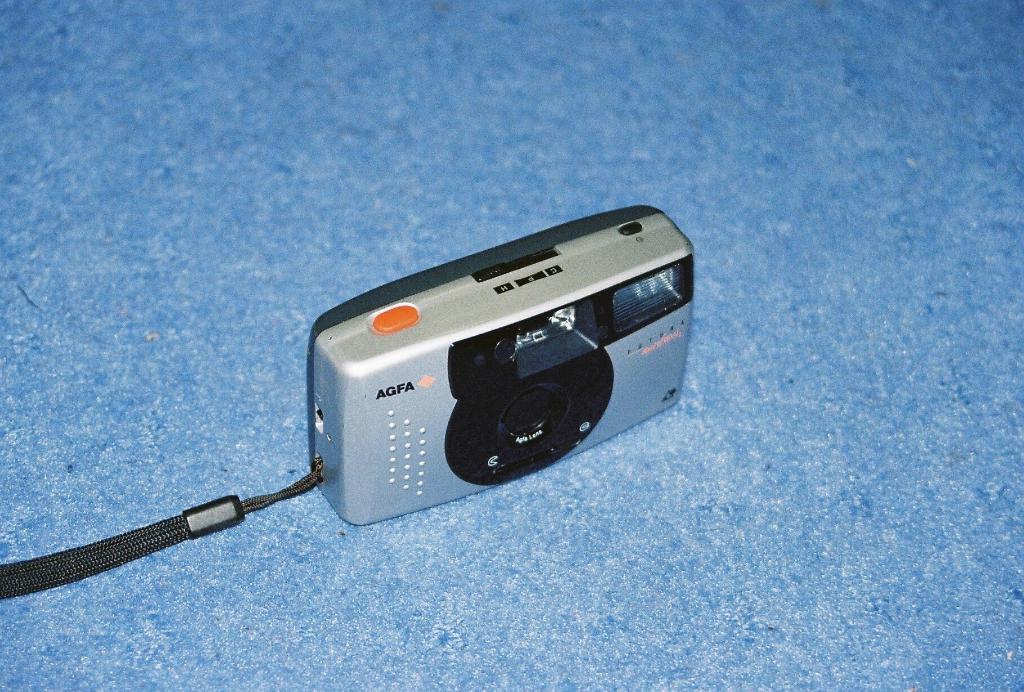Could you give a brief overview of what you see in this image? In this image we can see a camera on a blue surface. 